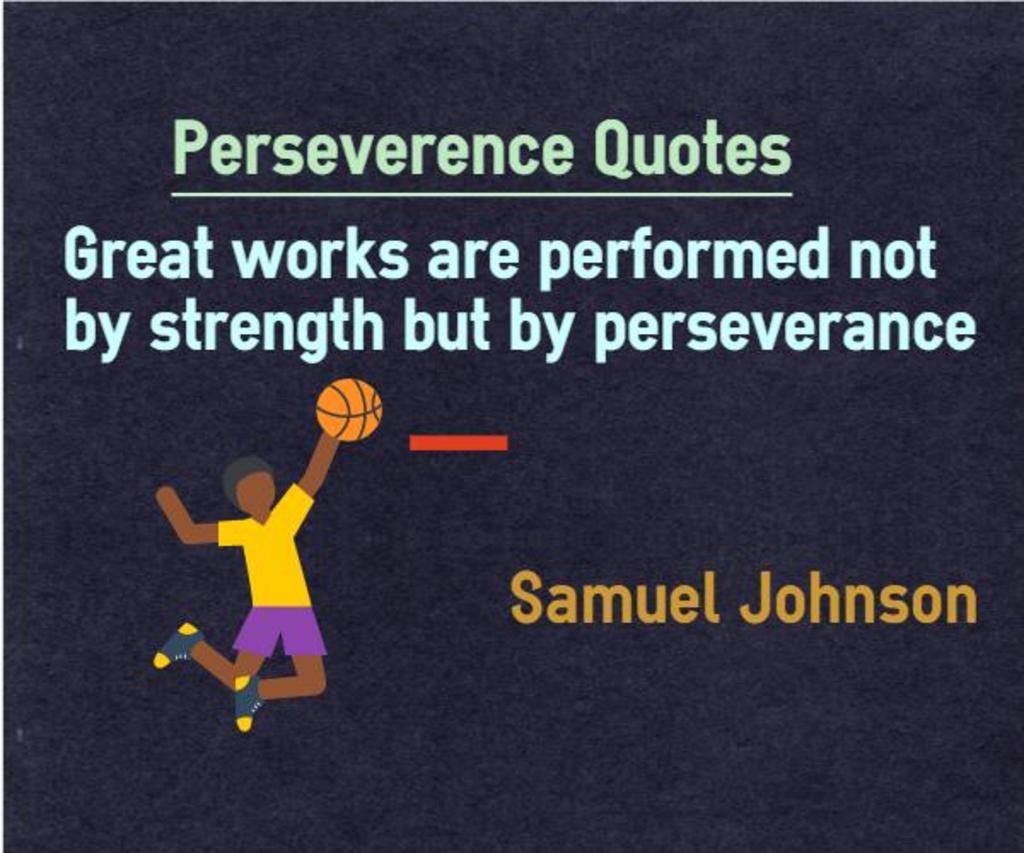Could you give a brief overview of what you see in this image? In this image we can see the picture of a person and a ball. We can also see some text on this image. 